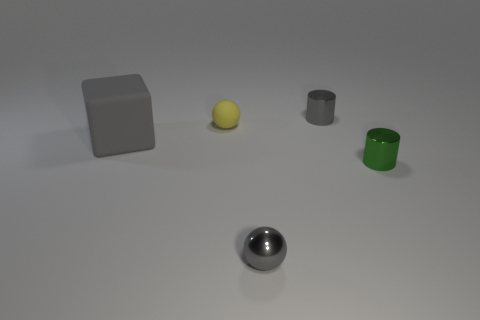Add 2 green cylinders. How many objects exist? 7 Subtract all cylinders. How many objects are left? 3 Subtract all gray spheres. Subtract all yellow rubber blocks. How many objects are left? 4 Add 5 small green objects. How many small green objects are left? 6 Add 2 gray metal objects. How many gray metal objects exist? 4 Subtract 1 gray balls. How many objects are left? 4 